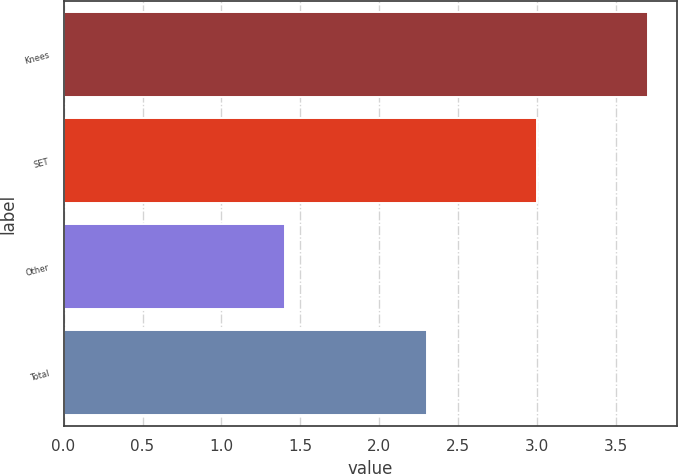Convert chart to OTSL. <chart><loc_0><loc_0><loc_500><loc_500><bar_chart><fcel>Knees<fcel>SET<fcel>Other<fcel>Total<nl><fcel>3.7<fcel>3<fcel>1.4<fcel>2.3<nl></chart> 